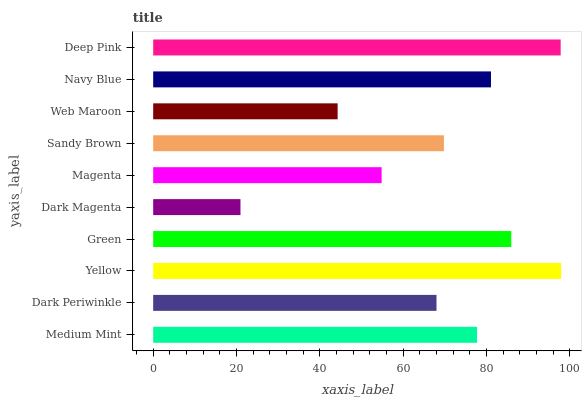Is Dark Magenta the minimum?
Answer yes or no. Yes. Is Yellow the maximum?
Answer yes or no. Yes. Is Dark Periwinkle the minimum?
Answer yes or no. No. Is Dark Periwinkle the maximum?
Answer yes or no. No. Is Medium Mint greater than Dark Periwinkle?
Answer yes or no. Yes. Is Dark Periwinkle less than Medium Mint?
Answer yes or no. Yes. Is Dark Periwinkle greater than Medium Mint?
Answer yes or no. No. Is Medium Mint less than Dark Periwinkle?
Answer yes or no. No. Is Medium Mint the high median?
Answer yes or no. Yes. Is Sandy Brown the low median?
Answer yes or no. Yes. Is Sandy Brown the high median?
Answer yes or no. No. Is Magenta the low median?
Answer yes or no. No. 